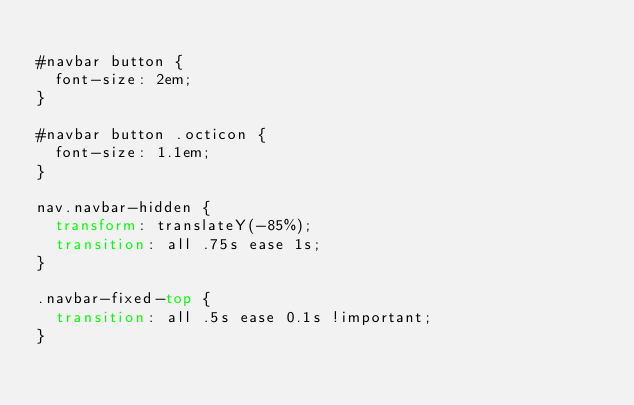<code> <loc_0><loc_0><loc_500><loc_500><_CSS_>
#navbar button {
  font-size: 2em;
}

#navbar button .octicon {
  font-size: 1.1em;
}

nav.navbar-hidden {
  transform: translateY(-85%);
  transition: all .75s ease 1s;
}

.navbar-fixed-top {
  transition: all .5s ease 0.1s !important;
}
</code> 